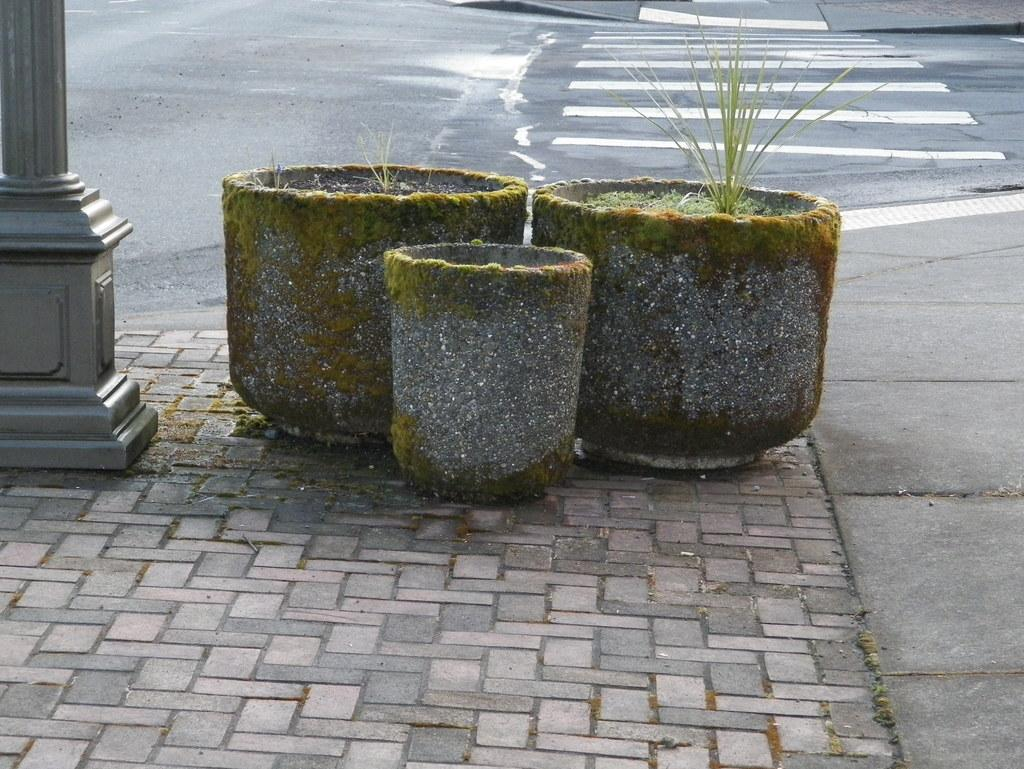What type of surface is at the bottom of the image? There is pavement at the bottom of the image. What objects can be seen in the middle of the image? There are cement flower pots in the middle of the image. What is located on the left side of the image? There is a pole on the left side of the image. What can be seen in the distance in the image? There is a road visible in the background of the image. What type of jeans is the house wearing in the image? There is no house present in the image, and therefore no clothing or accessories can be attributed to it. What show is being performed on the pole in the image? There is no show or performance taking place on the pole in the image; it is a stationary object. 